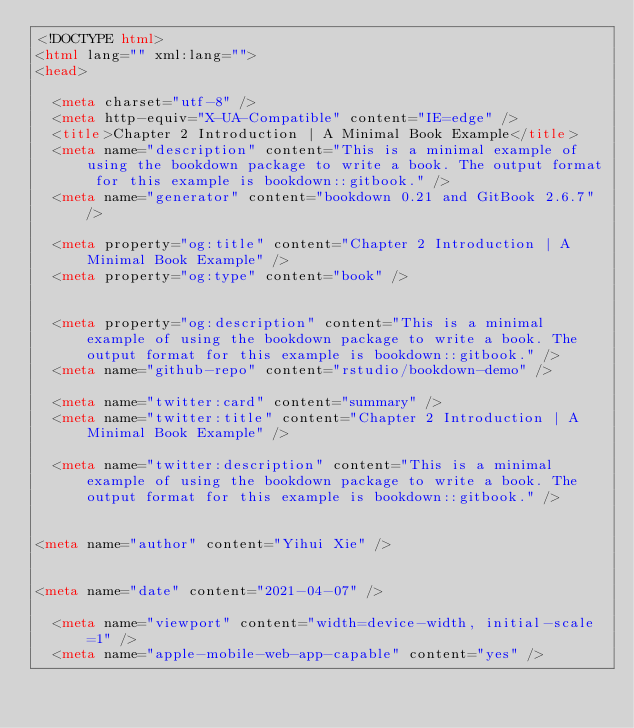Convert code to text. <code><loc_0><loc_0><loc_500><loc_500><_HTML_><!DOCTYPE html>
<html lang="" xml:lang="">
<head>

  <meta charset="utf-8" />
  <meta http-equiv="X-UA-Compatible" content="IE=edge" />
  <title>Chapter 2 Introduction | A Minimal Book Example</title>
  <meta name="description" content="This is a minimal example of using the bookdown package to write a book. The output format for this example is bookdown::gitbook." />
  <meta name="generator" content="bookdown 0.21 and GitBook 2.6.7" />

  <meta property="og:title" content="Chapter 2 Introduction | A Minimal Book Example" />
  <meta property="og:type" content="book" />
  
  
  <meta property="og:description" content="This is a minimal example of using the bookdown package to write a book. The output format for this example is bookdown::gitbook." />
  <meta name="github-repo" content="rstudio/bookdown-demo" />

  <meta name="twitter:card" content="summary" />
  <meta name="twitter:title" content="Chapter 2 Introduction | A Minimal Book Example" />
  
  <meta name="twitter:description" content="This is a minimal example of using the bookdown package to write a book. The output format for this example is bookdown::gitbook." />
  

<meta name="author" content="Yihui Xie" />


<meta name="date" content="2021-04-07" />

  <meta name="viewport" content="width=device-width, initial-scale=1" />
  <meta name="apple-mobile-web-app-capable" content="yes" /></code> 